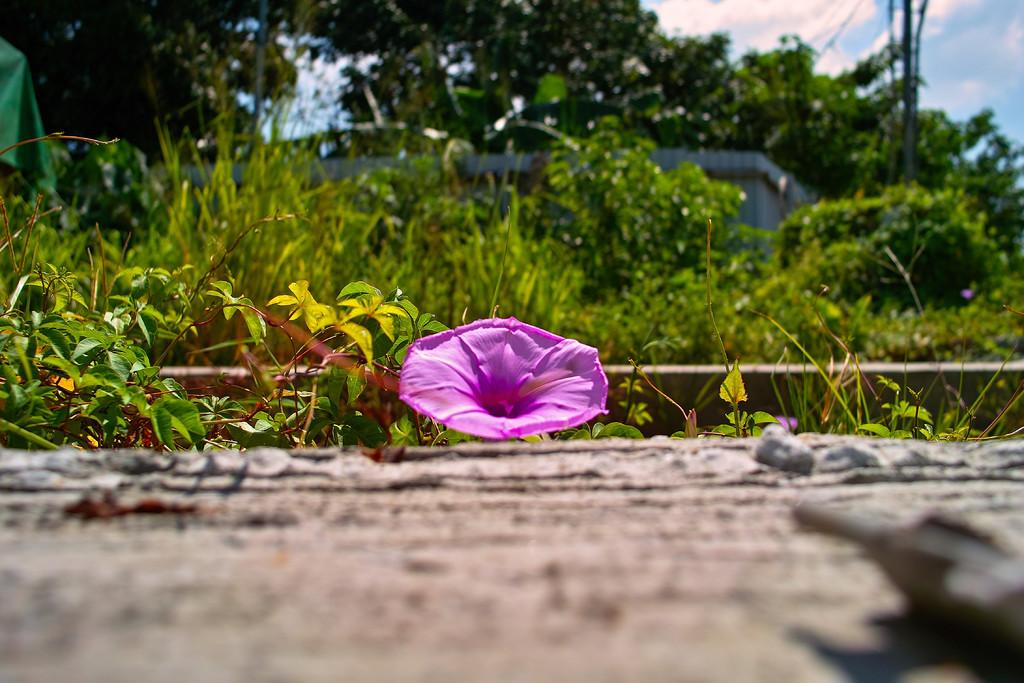What type of plant can be seen on the ground in the image? There is a flower present on the ground in the image. What other types of plants can be seen in the image? There are plants visible in the image. What type of vegetation is taller than the plants in the image? There are trees present in the image. What can be seen in the sky in the image? Clouds are visible in the sky in the image. Where is the seat located in the image? There is no seat present in the image. What type of grain can be seen growing in the image? There is no grain visible in the image. 